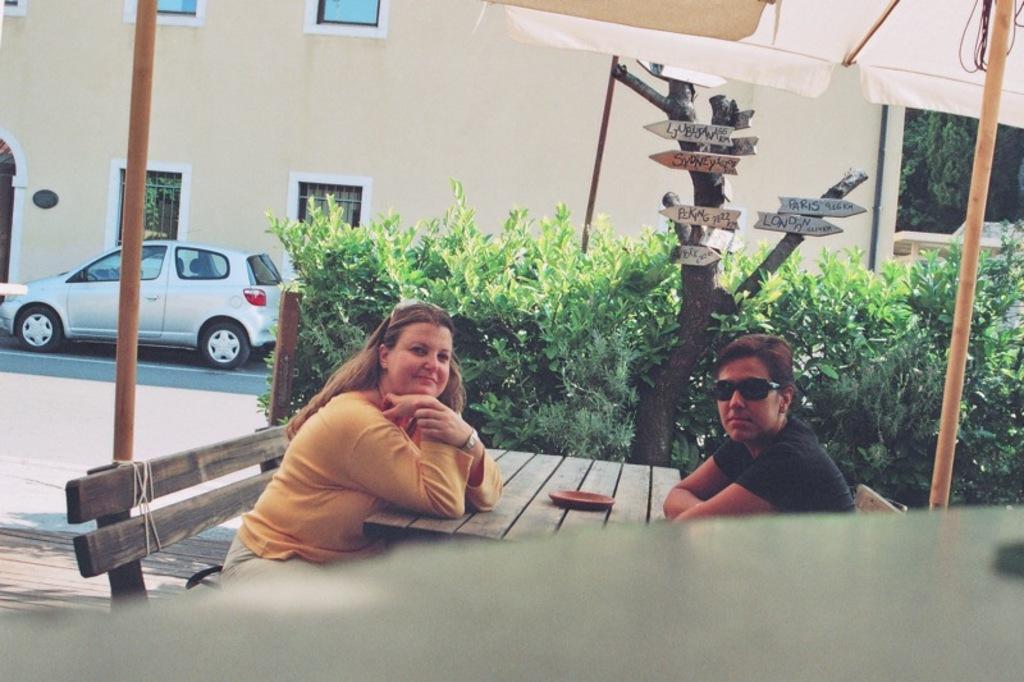Please provide a concise description of this image. In this image I can see two people are sitting on the bench. In front I can see something is on the table. Back I can see few buildings, windows, vehicle, poles, signboards, plants and tents. 